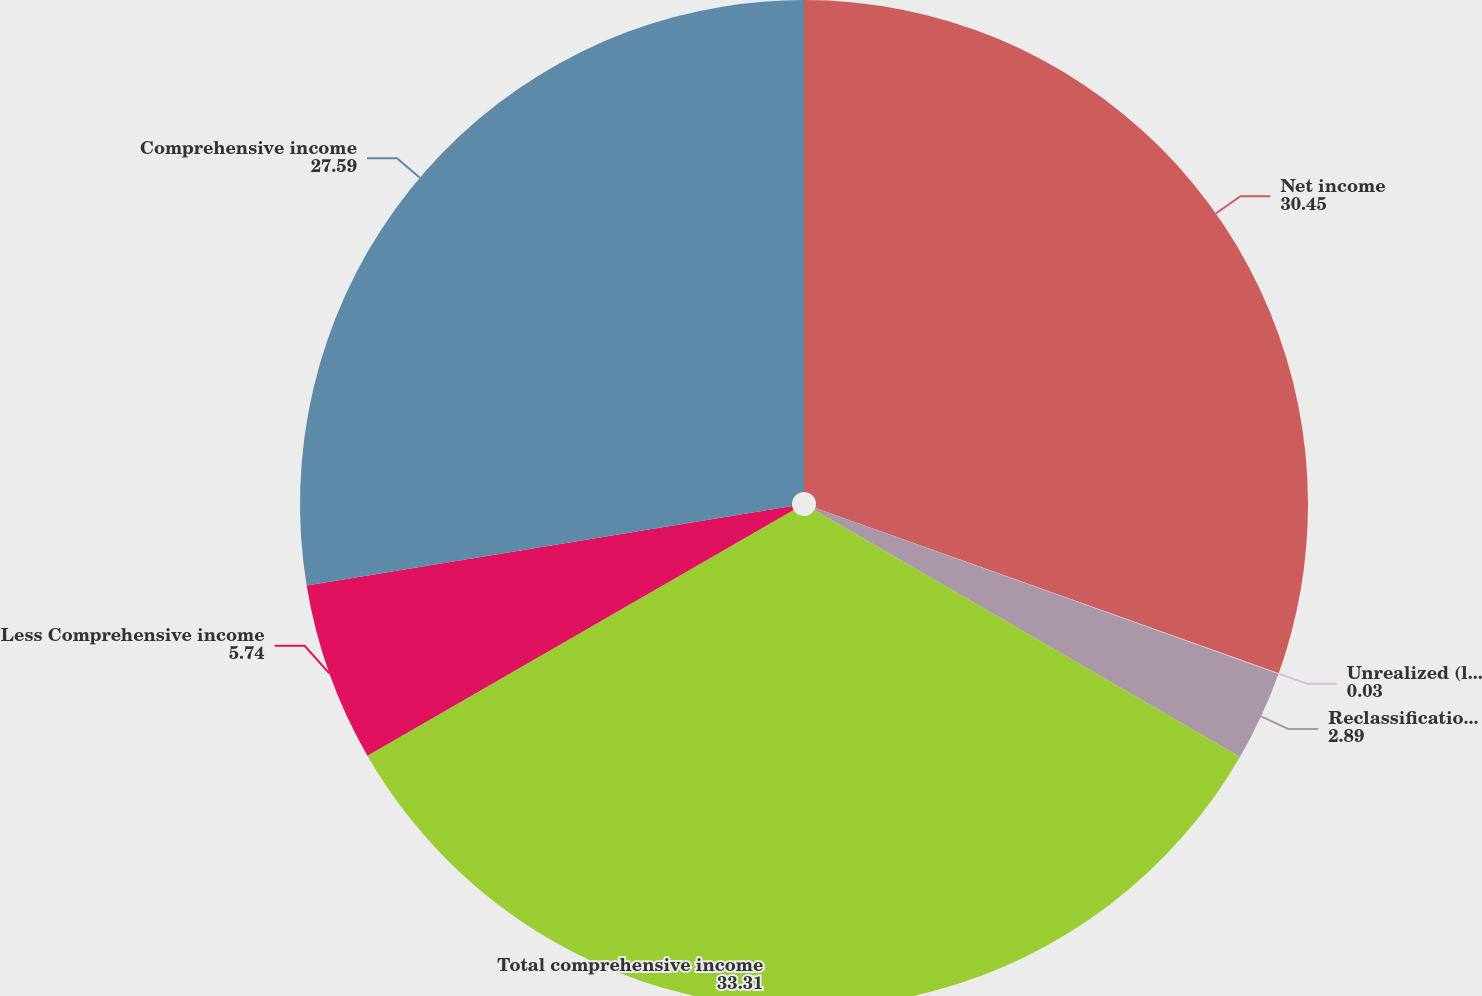Convert chart. <chart><loc_0><loc_0><loc_500><loc_500><pie_chart><fcel>Net income<fcel>Unrealized (loss) gain from<fcel>Reclassification adjustment<fcel>Total comprehensive income<fcel>Less Comprehensive income<fcel>Comprehensive income<nl><fcel>30.45%<fcel>0.03%<fcel>2.89%<fcel>33.31%<fcel>5.74%<fcel>27.59%<nl></chart> 